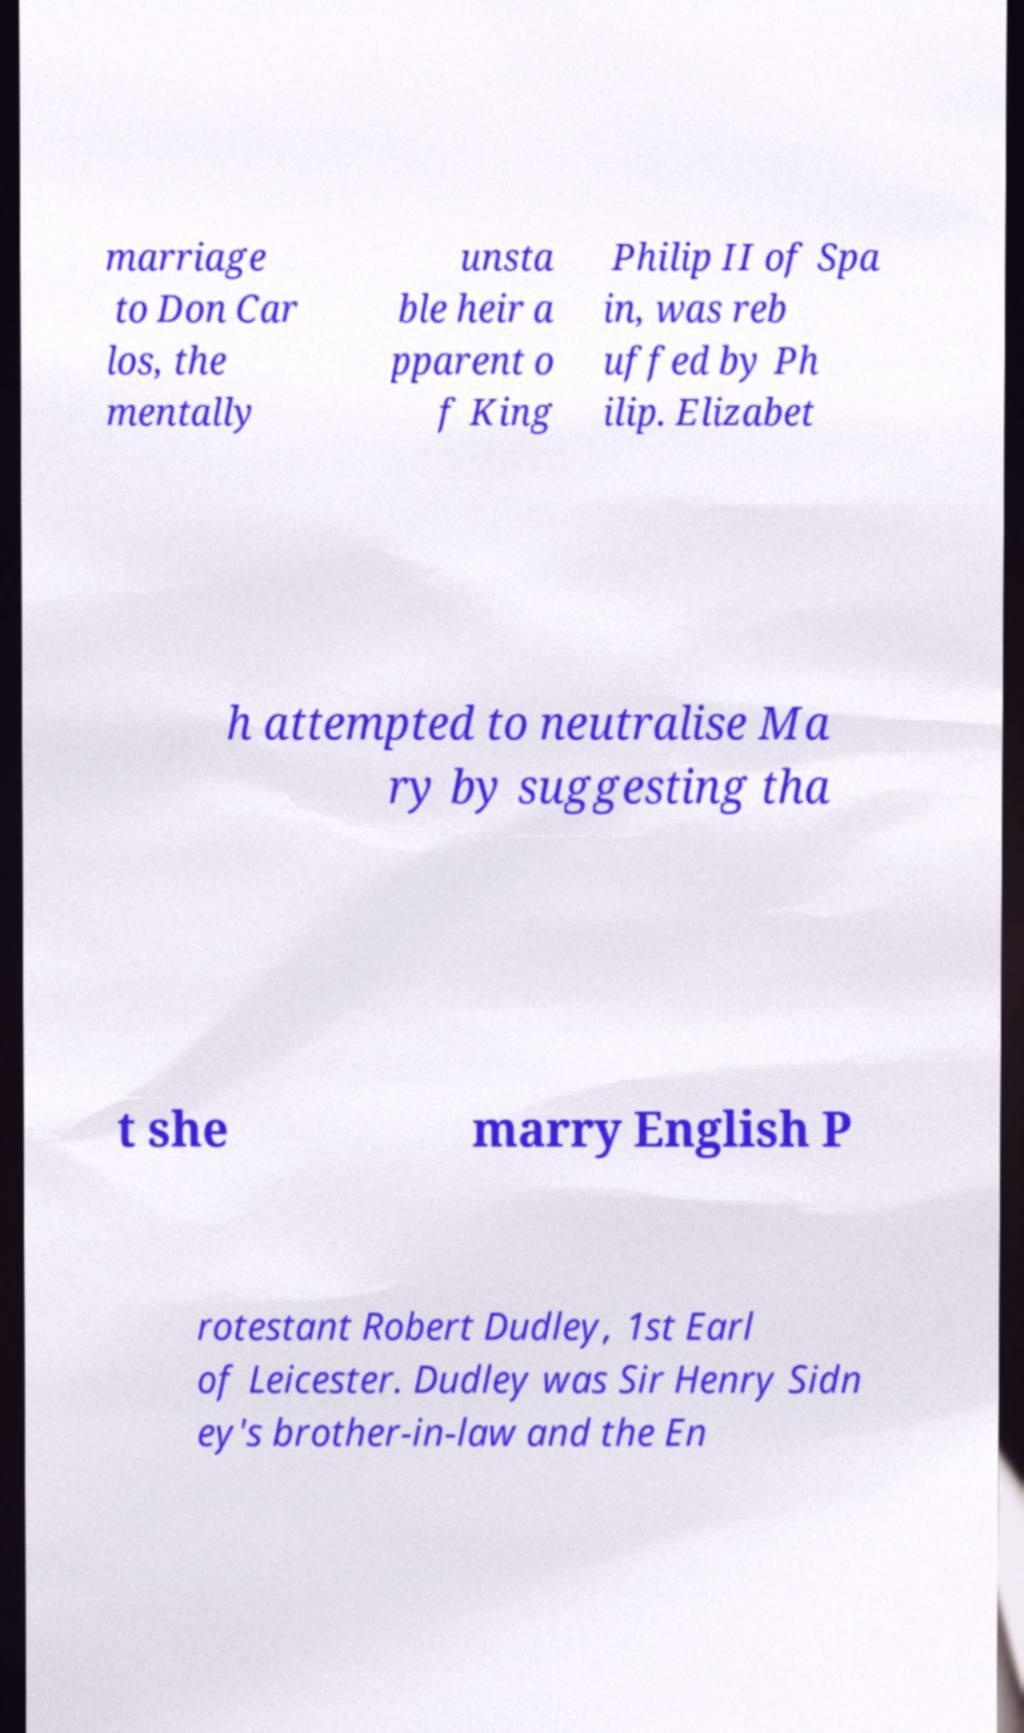For documentation purposes, I need the text within this image transcribed. Could you provide that? marriage to Don Car los, the mentally unsta ble heir a pparent o f King Philip II of Spa in, was reb uffed by Ph ilip. Elizabet h attempted to neutralise Ma ry by suggesting tha t she marry English P rotestant Robert Dudley, 1st Earl of Leicester. Dudley was Sir Henry Sidn ey's brother-in-law and the En 